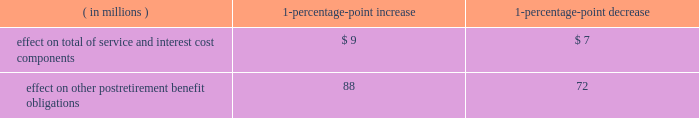Marathon oil corporation notes to consolidated financial statements assumed health care cost trend rates have a significant effect on the amounts reported for defined benefit retiree health care plans .
A one-percentage-point change in assumed health care cost trend rates would have the following effects : ( in millions ) 1-percentage- point increase 1-percentage- point decrease .
Plan investment policies and strategies the investment policies for our u.s .
And international pension plan assets reflect the funded status of the plans and expectations regarding our future ability to make further contributions .
Long-term investment goals are to : ( 1 ) manage the assets in accordance with the legal requirements of all applicable laws ; ( 2 ) produce investment returns which meet or exceed the rates of return achievable in the capital markets while maintaining the risk parameters set by the plans 2019 investment committees and protecting the assets from any erosion of purchasing power ; and ( 3 ) position the portfolios with a long-term risk/return orientation .
U.s .
Plans 2013 historical performance and future expectations suggest that common stocks will provide higher total investment returns than fixed income securities over a long-term investment horizon .
Short-term investments only reflect the liquidity requirements for making pension payments .
As such , the plans 2019 targeted asset allocation is comprised of 75 percent equity securities and 25 percent fixed income securities .
In the second quarter of 2009 , we exchanged the majority of our publicly-traded stocks and bonds for interests in pooled equity and fixed income investment funds from our outside manager , representing 58 percent and 20 percent of u.s .
Plan assets , respectively , as of december 31 , 2009 .
These funds are managed with the same style and strategy as when the securities were held separately .
Each fund 2019s main objective is to provide investors with exposure to either a publicly-traded equity or fixed income portfolio comprised of both u.s .
And non-u.s .
Securities .
The equity fund holdings primarily consist of publicly-traded individually-held securities in various sectors of many industries .
The fixed income fund holdings primarily consist of publicly-traded investment-grade bonds .
The plans 2019 assets are managed by a third-party investment manager .
The investment manager has limited discretion to move away from the target allocations based upon the manager 2019s judgment as to current confidence or concern regarding the capital markets .
Investments are diversified by industry and type , limited by grade and maturity .
The plans 2019 investment policy prohibits investments in any securities in the steel industry and allows derivatives subject to strict guidelines , such that derivatives may only be written against equity securities in the portfolio .
Investment performance and risk is measured and monitored on an ongoing basis through quarterly investment meetings and periodic asset and liability studies .
International plans 2013 our international plans 2019 target asset allocation is comprised of 70 percent equity securities and 30 percent fixed income securities .
The plan assets are invested in six separate portfolios , mainly pooled fund vehicles , managed by several professional investment managers .
Investments are diversified by industry and type , limited by grade and maturity .
The use of derivatives by the investment managers is permitted , subject to strict guidelines .
The investment managers 2019 performance is measured independently by a third-party asset servicing consulting firm .
Overall , investment performance and risk is measured and monitored on an ongoing basis through quarterly investment portfolio reviews and periodic asset and liability studies .
Fair value measurements plan assets are measured at fair value .
The definition and approaches to measuring fair value and the three levels of the fair value hierarchy are described in note 16 .
The following provides a description of the valuation techniques employed for each major plan asset category at december 31 , 2009 and 2008 .
Cash and cash equivalents 2013 cash and cash equivalents include cash on deposit and an investment in a money market mutual fund that invests mainly in short-term instruments and cash , both of which are valued using a .
What would the effect on other postretirement benefit obligations be if there was a 2-percent point increase? 
Computations: (88 * 2)
Answer: 176.0. 